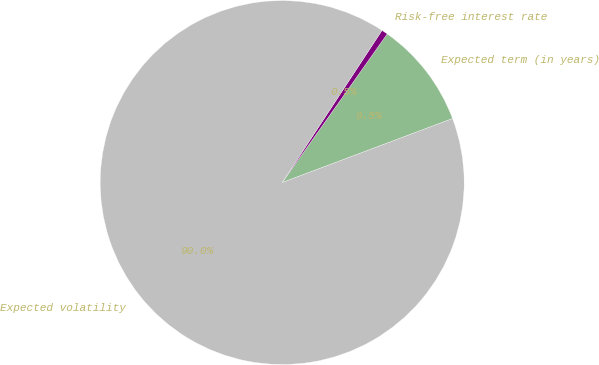<chart> <loc_0><loc_0><loc_500><loc_500><pie_chart><fcel>Expected term (in years)<fcel>Risk-free interest rate<fcel>Expected volatility<nl><fcel>9.49%<fcel>0.55%<fcel>89.97%<nl></chart> 